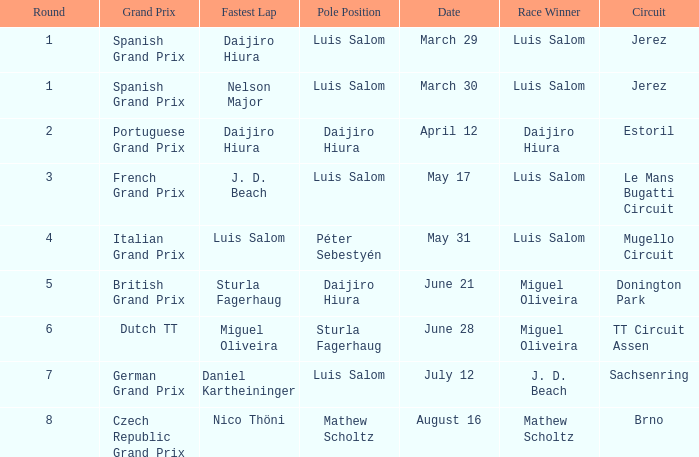Which round 5 Grand Prix had Daijiro Hiura at pole position?  British Grand Prix. Write the full table. {'header': ['Round', 'Grand Prix', 'Fastest Lap', 'Pole Position', 'Date', 'Race Winner', 'Circuit'], 'rows': [['1', 'Spanish Grand Prix', 'Daijiro Hiura', 'Luis Salom', 'March 29', 'Luis Salom', 'Jerez'], ['1', 'Spanish Grand Prix', 'Nelson Major', 'Luis Salom', 'March 30', 'Luis Salom', 'Jerez'], ['2', 'Portuguese Grand Prix', 'Daijiro Hiura', 'Daijiro Hiura', 'April 12', 'Daijiro Hiura', 'Estoril'], ['3', 'French Grand Prix', 'J. D. Beach', 'Luis Salom', 'May 17', 'Luis Salom', 'Le Mans Bugatti Circuit'], ['4', 'Italian Grand Prix', 'Luis Salom', 'Péter Sebestyén', 'May 31', 'Luis Salom', 'Mugello Circuit'], ['5', 'British Grand Prix', 'Sturla Fagerhaug', 'Daijiro Hiura', 'June 21', 'Miguel Oliveira', 'Donington Park'], ['6', 'Dutch TT', 'Miguel Oliveira', 'Sturla Fagerhaug', 'June 28', 'Miguel Oliveira', 'TT Circuit Assen'], ['7', 'German Grand Prix', 'Daniel Kartheininger', 'Luis Salom', 'July 12', 'J. D. Beach', 'Sachsenring'], ['8', 'Czech Republic Grand Prix', 'Nico Thöni', 'Mathew Scholtz', 'August 16', 'Mathew Scholtz', 'Brno']]} 